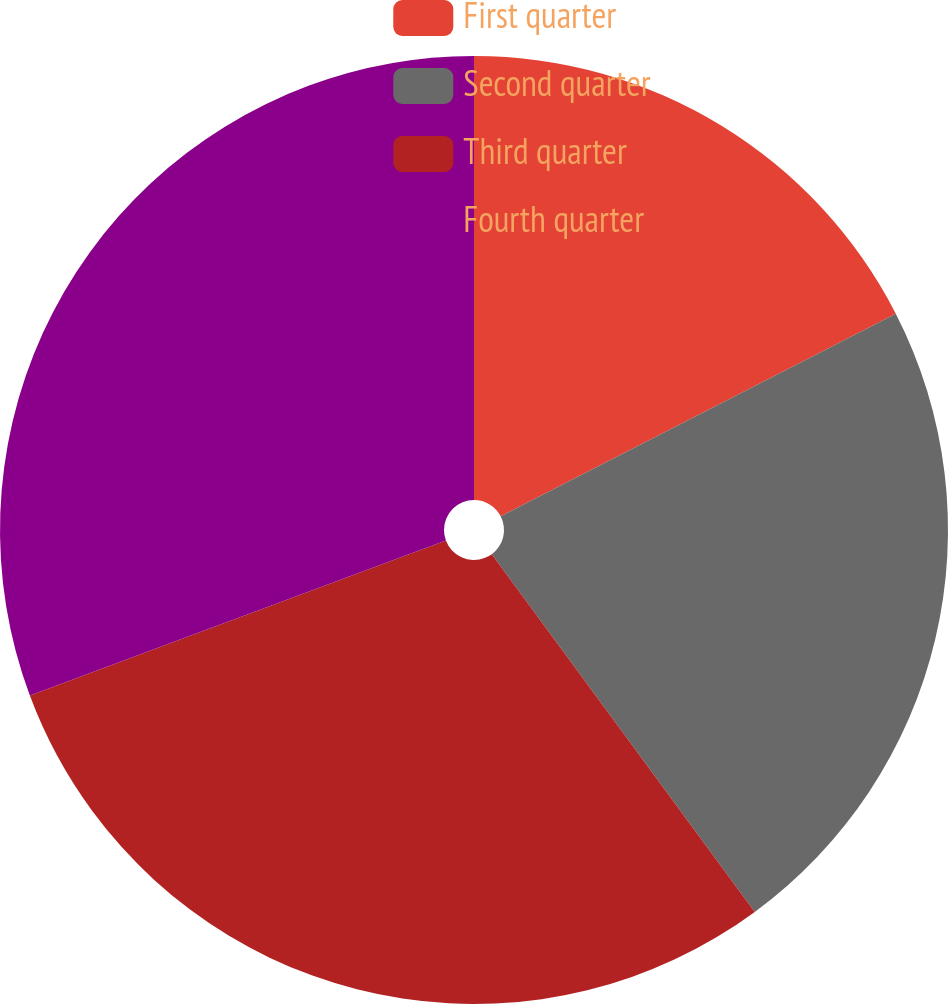Convert chart. <chart><loc_0><loc_0><loc_500><loc_500><pie_chart><fcel>First quarter<fcel>Second quarter<fcel>Third quarter<fcel>Fourth quarter<nl><fcel>17.46%<fcel>22.45%<fcel>29.41%<fcel>30.68%<nl></chart> 